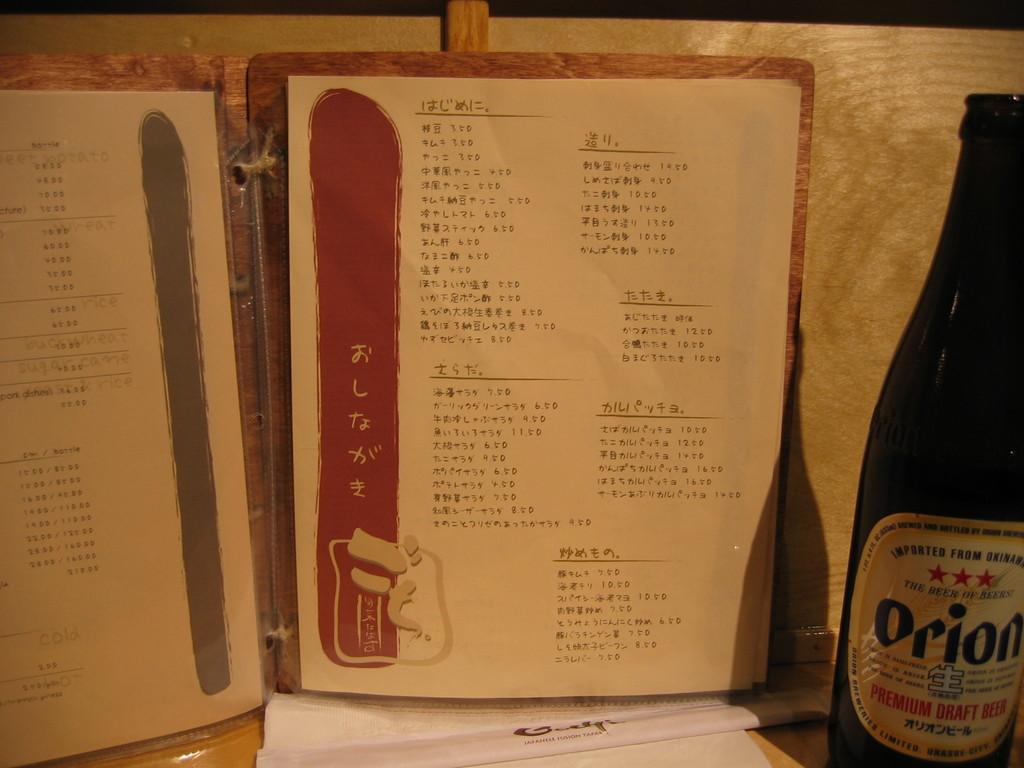What kind of beverage is in the bottle?
Make the answer very short. Orion. 